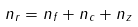<formula> <loc_0><loc_0><loc_500><loc_500>n _ { r } = n _ { f } + n _ { c } + n _ { z }</formula> 